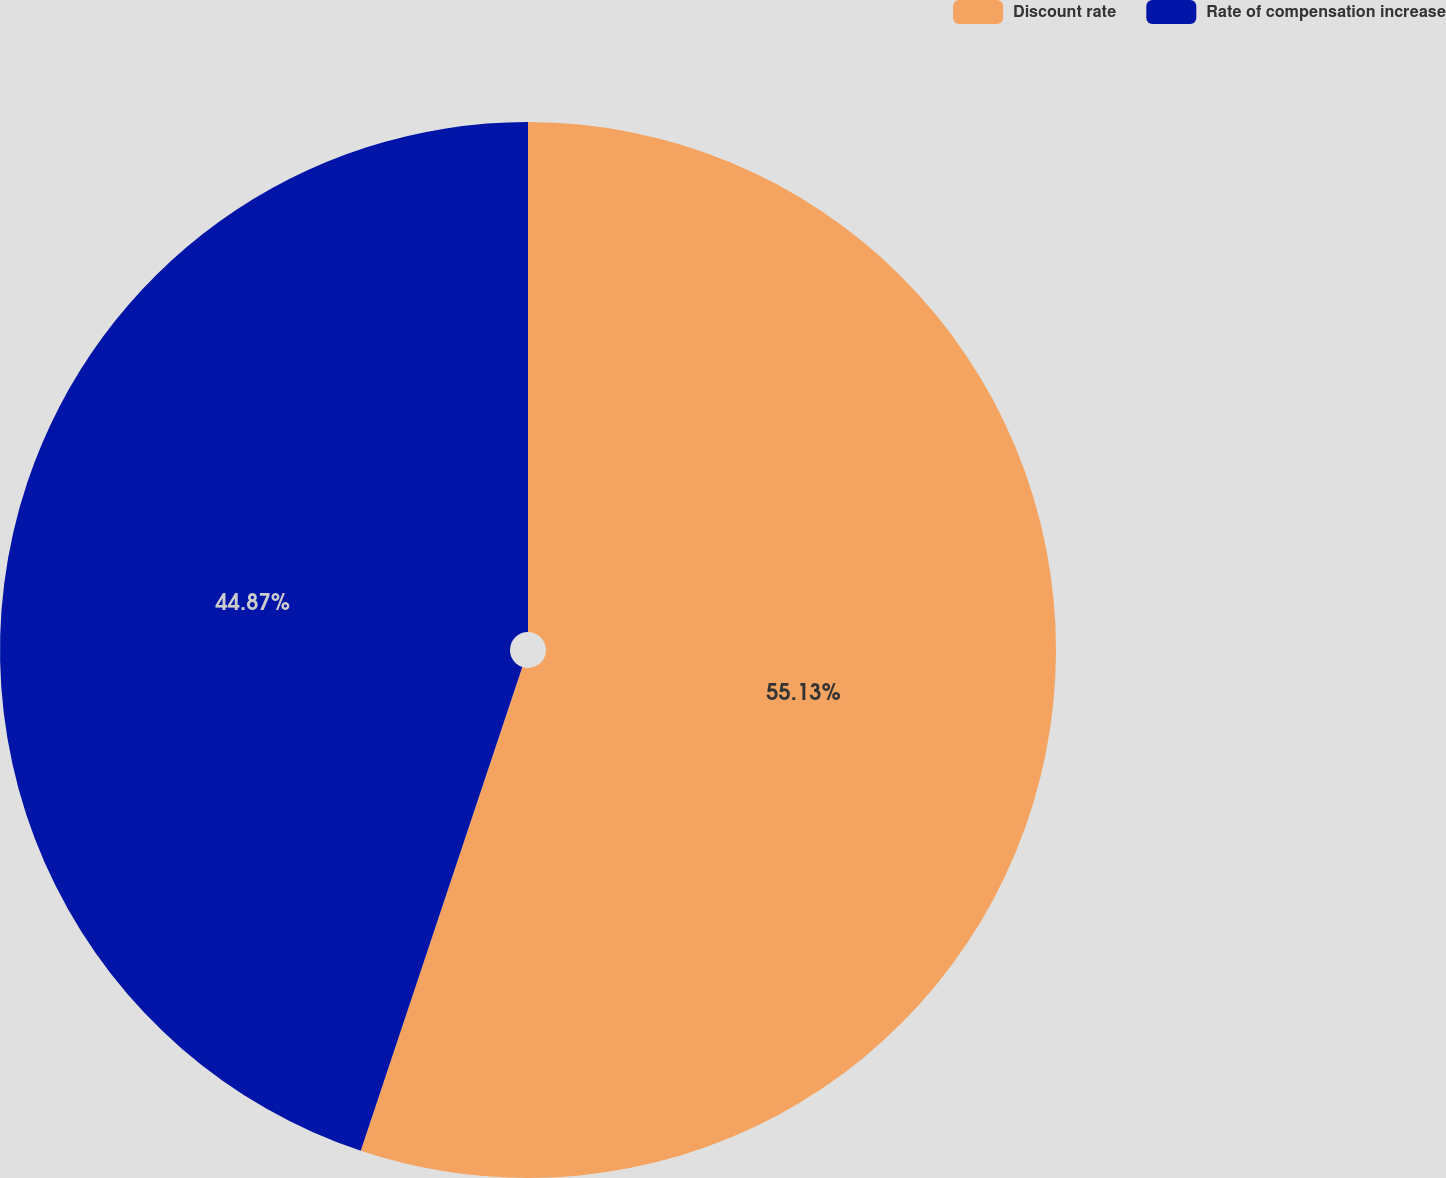Convert chart to OTSL. <chart><loc_0><loc_0><loc_500><loc_500><pie_chart><fcel>Discount rate<fcel>Rate of compensation increase<nl><fcel>55.13%<fcel>44.87%<nl></chart> 